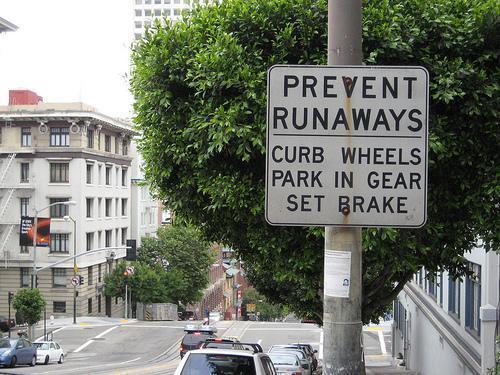How many words are on the sign?
Give a very brief answer. 9. 